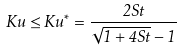Convert formula to latex. <formula><loc_0><loc_0><loc_500><loc_500>K u \leq K u ^ { * } = \frac { 2 S t } { \sqrt { 1 + 4 S t } - 1 }</formula> 